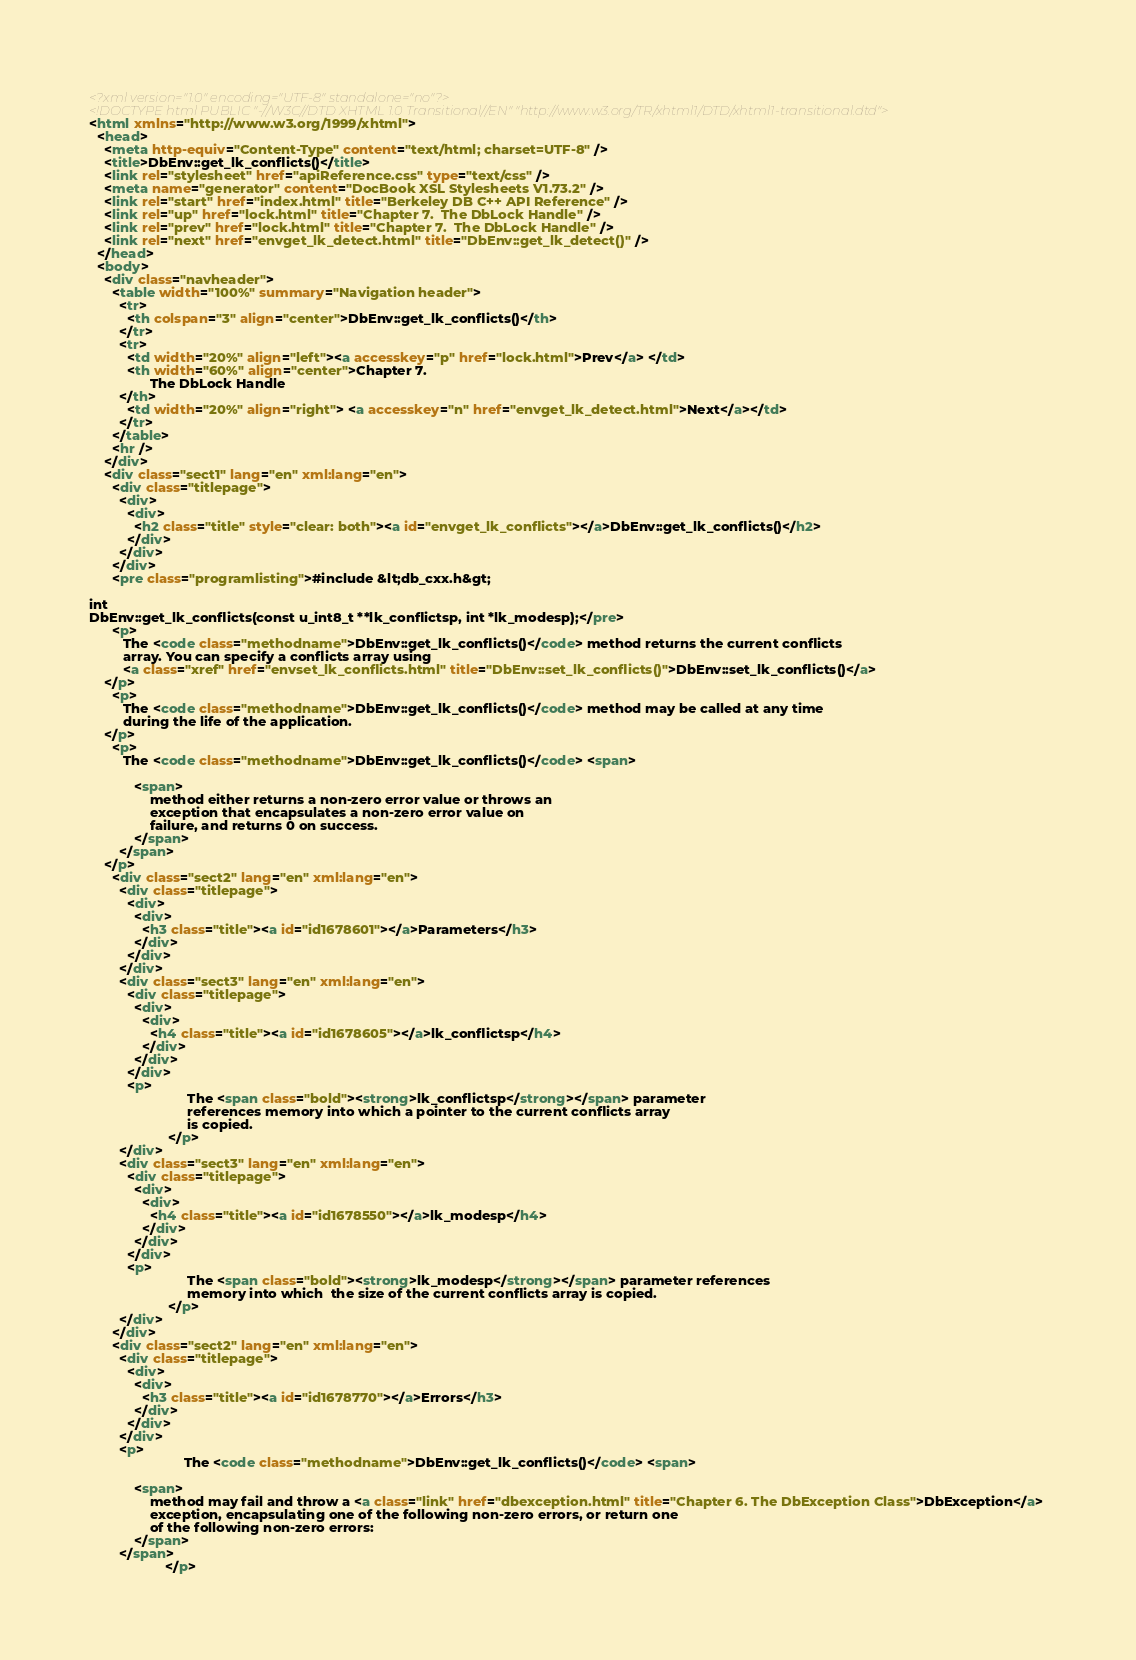Convert code to text. <code><loc_0><loc_0><loc_500><loc_500><_HTML_><?xml version="1.0" encoding="UTF-8" standalone="no"?>
<!DOCTYPE html PUBLIC "-//W3C//DTD XHTML 1.0 Transitional//EN" "http://www.w3.org/TR/xhtml1/DTD/xhtml1-transitional.dtd">
<html xmlns="http://www.w3.org/1999/xhtml">
  <head>
    <meta http-equiv="Content-Type" content="text/html; charset=UTF-8" />
    <title>DbEnv::get_lk_conflicts()</title>
    <link rel="stylesheet" href="apiReference.css" type="text/css" />
    <meta name="generator" content="DocBook XSL Stylesheets V1.73.2" />
    <link rel="start" href="index.html" title="Berkeley DB C++ API Reference" />
    <link rel="up" href="lock.html" title="Chapter 7.  The DbLock Handle" />
    <link rel="prev" href="lock.html" title="Chapter 7.  The DbLock Handle" />
    <link rel="next" href="envget_lk_detect.html" title="DbEnv::get_lk_detect()" />
  </head>
  <body>
    <div class="navheader">
      <table width="100%" summary="Navigation header">
        <tr>
          <th colspan="3" align="center">DbEnv::get_lk_conflicts()</th>
        </tr>
        <tr>
          <td width="20%" align="left"><a accesskey="p" href="lock.html">Prev</a> </td>
          <th width="60%" align="center">Chapter 7. 
                The DbLock Handle
        </th>
          <td width="20%" align="right"> <a accesskey="n" href="envget_lk_detect.html">Next</a></td>
        </tr>
      </table>
      <hr />
    </div>
    <div class="sect1" lang="en" xml:lang="en">
      <div class="titlepage">
        <div>
          <div>
            <h2 class="title" style="clear: both"><a id="envget_lk_conflicts"></a>DbEnv::get_lk_conflicts()</h2>
          </div>
        </div>
      </div>
      <pre class="programlisting">#include &lt;db_cxx.h&gt;

int
DbEnv::get_lk_conflicts(const u_int8_t **lk_conflictsp, int *lk_modesp);</pre>
      <p>
         The <code class="methodname">DbEnv::get_lk_conflicts()</code> method returns the current conflicts
         array. You can specify a conflicts array using 
         <a class="xref" href="envset_lk_conflicts.html" title="DbEnv::set_lk_conflicts()">DbEnv::set_lk_conflicts()</a>
    </p>
      <p>
         The <code class="methodname">DbEnv::get_lk_conflicts()</code> method may be called at any time
         during the life of the application.
    </p>
      <p>
         The <code class="methodname">DbEnv::get_lk_conflicts()</code> <span>
            
            <span>
                method either returns a non-zero error value or throws an
                exception that encapsulates a non-zero error value on
                failure, and returns 0 on success.
            </span>
        </span>
    </p>
      <div class="sect2" lang="en" xml:lang="en">
        <div class="titlepage">
          <div>
            <div>
              <h3 class="title"><a id="id1678601"></a>Parameters</h3>
            </div>
          </div>
        </div>
        <div class="sect3" lang="en" xml:lang="en">
          <div class="titlepage">
            <div>
              <div>
                <h4 class="title"><a id="id1678605"></a>lk_conflictsp</h4>
              </div>
            </div>
          </div>
          <p>
                          The <span class="bold"><strong>lk_conflictsp</strong></span> parameter
                          references memory into which a pointer to the current conflicts array
                          is copied.
                     </p>
        </div>
        <div class="sect3" lang="en" xml:lang="en">
          <div class="titlepage">
            <div>
              <div>
                <h4 class="title"><a id="id1678550"></a>lk_modesp</h4>
              </div>
            </div>
          </div>
          <p>
                          The <span class="bold"><strong>lk_modesp</strong></span> parameter references
                          memory into which  the size of the current conflicts array is copied.
                     </p>
        </div>
      </div>
      <div class="sect2" lang="en" xml:lang="en">
        <div class="titlepage">
          <div>
            <div>
              <h3 class="title"><a id="id1678770"></a>Errors</h3>
            </div>
          </div>
        </div>
        <p>
                         The <code class="methodname">DbEnv::get_lk_conflicts()</code> <span>
            
            <span>
                method may fail and throw a <a class="link" href="dbexception.html" title="Chapter 6. The DbException Class">DbException</a> 
                exception, encapsulating one of the following non-zero errors, or return one
                of the following non-zero errors:
            </span>
        </span>
                    </p></code> 